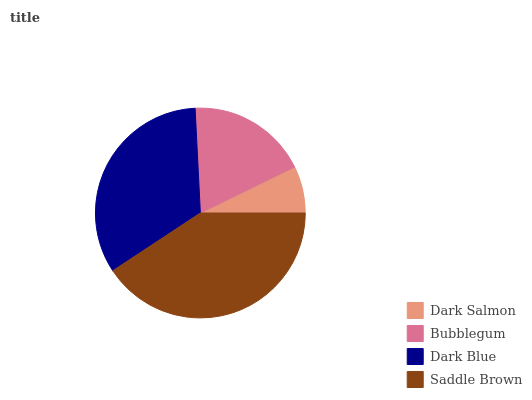Is Dark Salmon the minimum?
Answer yes or no. Yes. Is Saddle Brown the maximum?
Answer yes or no. Yes. Is Bubblegum the minimum?
Answer yes or no. No. Is Bubblegum the maximum?
Answer yes or no. No. Is Bubblegum greater than Dark Salmon?
Answer yes or no. Yes. Is Dark Salmon less than Bubblegum?
Answer yes or no. Yes. Is Dark Salmon greater than Bubblegum?
Answer yes or no. No. Is Bubblegum less than Dark Salmon?
Answer yes or no. No. Is Dark Blue the high median?
Answer yes or no. Yes. Is Bubblegum the low median?
Answer yes or no. Yes. Is Saddle Brown the high median?
Answer yes or no. No. Is Saddle Brown the low median?
Answer yes or no. No. 